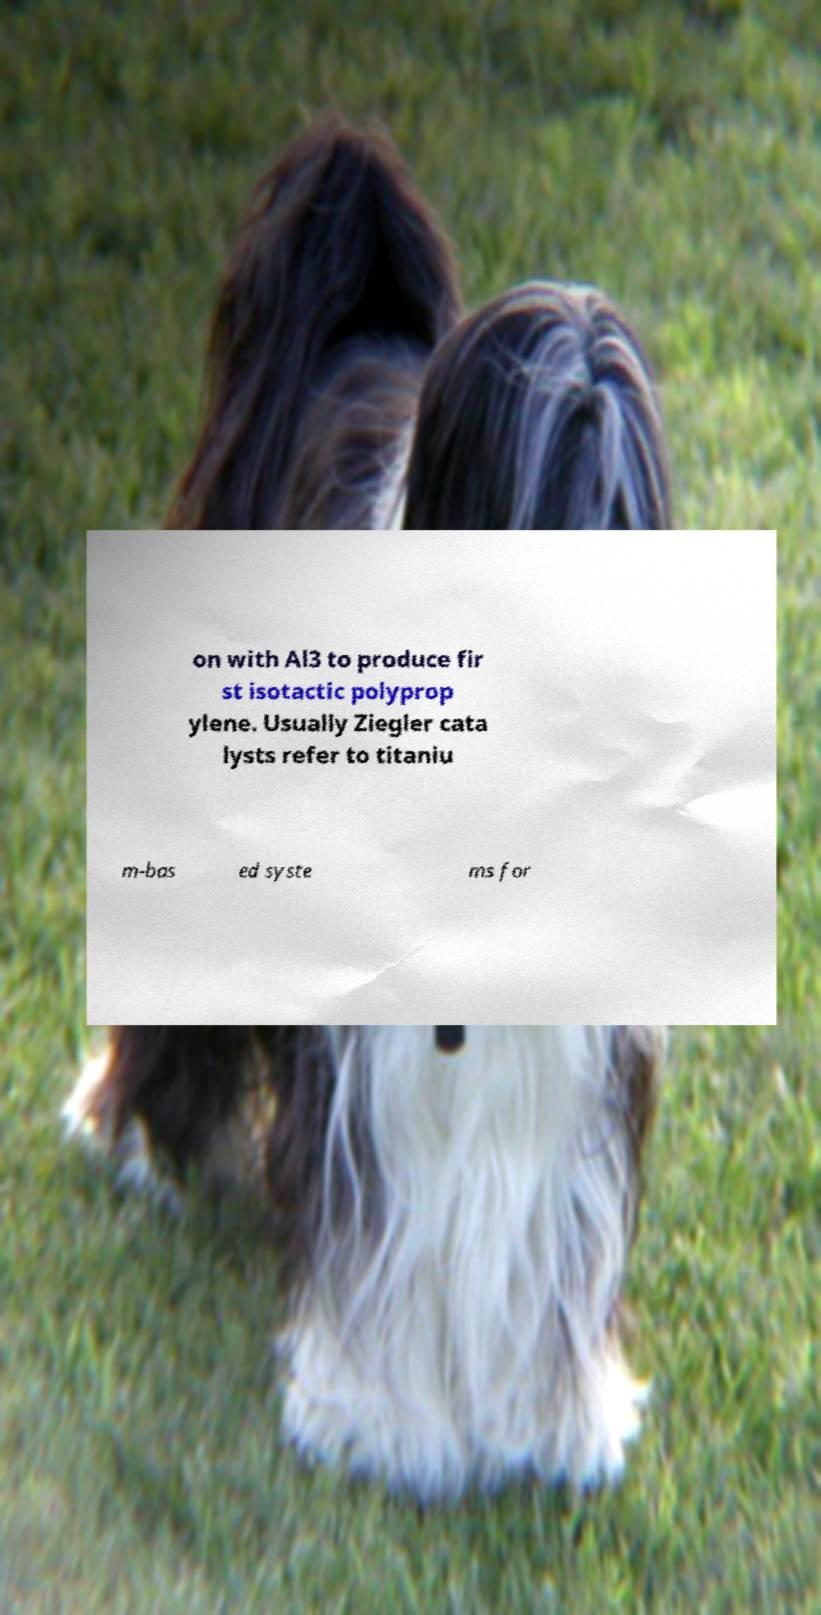For documentation purposes, I need the text within this image transcribed. Could you provide that? on with Al3 to produce fir st isotactic polyprop ylene. Usually Ziegler cata lysts refer to titaniu m-bas ed syste ms for 